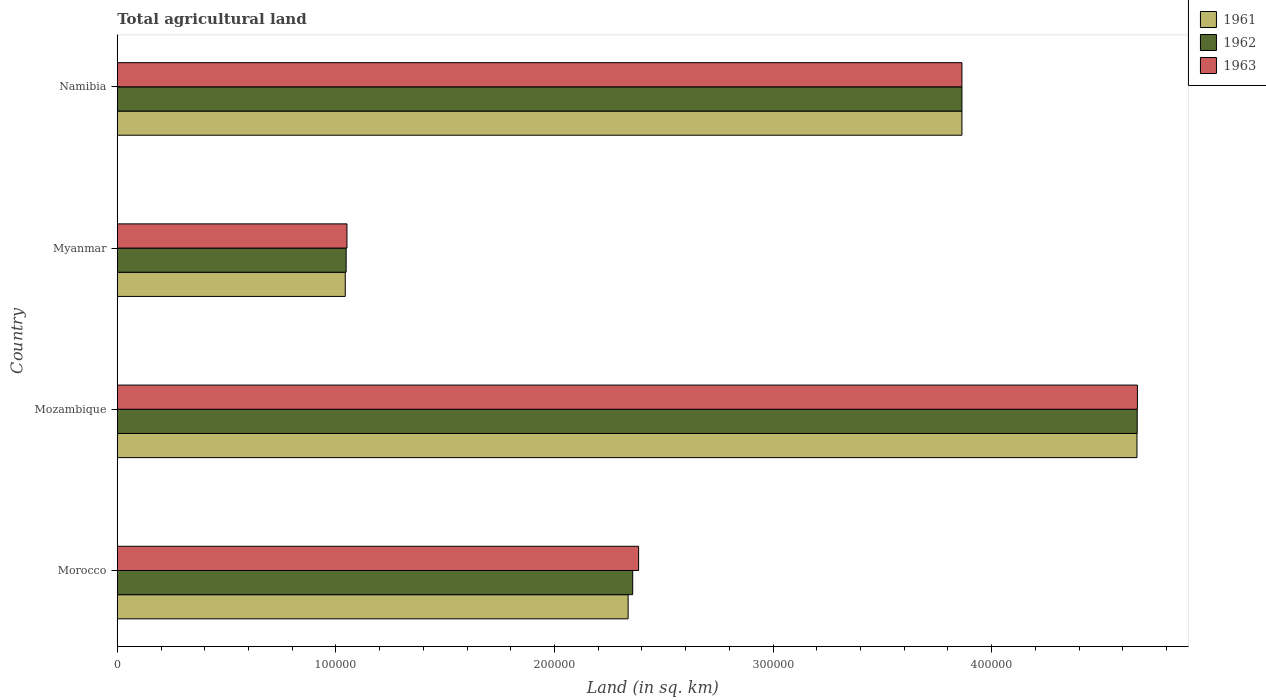How many different coloured bars are there?
Your answer should be compact. 3. How many groups of bars are there?
Provide a short and direct response. 4. How many bars are there on the 3rd tick from the top?
Your answer should be compact. 3. What is the label of the 1st group of bars from the top?
Provide a succinct answer. Namibia. In how many cases, is the number of bars for a given country not equal to the number of legend labels?
Provide a short and direct response. 0. What is the total agricultural land in 1962 in Namibia?
Your answer should be very brief. 3.86e+05. Across all countries, what is the maximum total agricultural land in 1961?
Your response must be concise. 4.66e+05. Across all countries, what is the minimum total agricultural land in 1962?
Give a very brief answer. 1.05e+05. In which country was the total agricultural land in 1963 maximum?
Give a very brief answer. Mozambique. In which country was the total agricultural land in 1962 minimum?
Your answer should be very brief. Myanmar. What is the total total agricultural land in 1963 in the graph?
Give a very brief answer. 1.20e+06. What is the difference between the total agricultural land in 1961 in Morocco and that in Mozambique?
Provide a succinct answer. -2.33e+05. What is the difference between the total agricultural land in 1961 in Myanmar and the total agricultural land in 1963 in Mozambique?
Your answer should be very brief. -3.62e+05. What is the average total agricultural land in 1961 per country?
Give a very brief answer. 2.98e+05. What is the difference between the total agricultural land in 1962 and total agricultural land in 1961 in Mozambique?
Your response must be concise. 110. What is the ratio of the total agricultural land in 1963 in Morocco to that in Myanmar?
Keep it short and to the point. 2.27. Is the total agricultural land in 1962 in Morocco less than that in Mozambique?
Make the answer very short. Yes. What is the difference between the highest and the second highest total agricultural land in 1961?
Your response must be concise. 8.01e+04. What is the difference between the highest and the lowest total agricultural land in 1961?
Make the answer very short. 3.62e+05. Is the sum of the total agricultural land in 1961 in Morocco and Myanmar greater than the maximum total agricultural land in 1962 across all countries?
Make the answer very short. No. What does the 3rd bar from the top in Myanmar represents?
Give a very brief answer. 1961. Is it the case that in every country, the sum of the total agricultural land in 1963 and total agricultural land in 1961 is greater than the total agricultural land in 1962?
Your answer should be very brief. Yes. How many bars are there?
Offer a very short reply. 12. How many countries are there in the graph?
Make the answer very short. 4. Are the values on the major ticks of X-axis written in scientific E-notation?
Your answer should be very brief. No. What is the title of the graph?
Your response must be concise. Total agricultural land. Does "1989" appear as one of the legend labels in the graph?
Your answer should be compact. No. What is the label or title of the X-axis?
Offer a terse response. Land (in sq. km). What is the label or title of the Y-axis?
Your response must be concise. Country. What is the Land (in sq. km) in 1961 in Morocco?
Your answer should be very brief. 2.34e+05. What is the Land (in sq. km) in 1962 in Morocco?
Ensure brevity in your answer.  2.36e+05. What is the Land (in sq. km) in 1963 in Morocco?
Your answer should be compact. 2.38e+05. What is the Land (in sq. km) in 1961 in Mozambique?
Provide a succinct answer. 4.66e+05. What is the Land (in sq. km) of 1962 in Mozambique?
Offer a terse response. 4.67e+05. What is the Land (in sq. km) of 1963 in Mozambique?
Keep it short and to the point. 4.67e+05. What is the Land (in sq. km) of 1961 in Myanmar?
Provide a short and direct response. 1.04e+05. What is the Land (in sq. km) of 1962 in Myanmar?
Your answer should be very brief. 1.05e+05. What is the Land (in sq. km) of 1963 in Myanmar?
Provide a short and direct response. 1.05e+05. What is the Land (in sq. km) of 1961 in Namibia?
Your answer should be very brief. 3.86e+05. What is the Land (in sq. km) of 1962 in Namibia?
Offer a terse response. 3.86e+05. What is the Land (in sq. km) in 1963 in Namibia?
Your answer should be compact. 3.86e+05. Across all countries, what is the maximum Land (in sq. km) of 1961?
Ensure brevity in your answer.  4.66e+05. Across all countries, what is the maximum Land (in sq. km) in 1962?
Ensure brevity in your answer.  4.67e+05. Across all countries, what is the maximum Land (in sq. km) in 1963?
Your answer should be compact. 4.67e+05. Across all countries, what is the minimum Land (in sq. km) of 1961?
Provide a succinct answer. 1.04e+05. Across all countries, what is the minimum Land (in sq. km) of 1962?
Provide a succinct answer. 1.05e+05. Across all countries, what is the minimum Land (in sq. km) of 1963?
Provide a succinct answer. 1.05e+05. What is the total Land (in sq. km) of 1961 in the graph?
Provide a succinct answer. 1.19e+06. What is the total Land (in sq. km) of 1962 in the graph?
Provide a succinct answer. 1.19e+06. What is the total Land (in sq. km) of 1963 in the graph?
Your response must be concise. 1.20e+06. What is the difference between the Land (in sq. km) in 1961 in Morocco and that in Mozambique?
Offer a very short reply. -2.33e+05. What is the difference between the Land (in sq. km) in 1962 in Morocco and that in Mozambique?
Offer a terse response. -2.31e+05. What is the difference between the Land (in sq. km) in 1963 in Morocco and that in Mozambique?
Your answer should be very brief. -2.28e+05. What is the difference between the Land (in sq. km) in 1961 in Morocco and that in Myanmar?
Keep it short and to the point. 1.29e+05. What is the difference between the Land (in sq. km) of 1962 in Morocco and that in Myanmar?
Keep it short and to the point. 1.31e+05. What is the difference between the Land (in sq. km) of 1963 in Morocco and that in Myanmar?
Your answer should be very brief. 1.33e+05. What is the difference between the Land (in sq. km) in 1961 in Morocco and that in Namibia?
Provide a short and direct response. -1.53e+05. What is the difference between the Land (in sq. km) of 1962 in Morocco and that in Namibia?
Ensure brevity in your answer.  -1.51e+05. What is the difference between the Land (in sq. km) of 1963 in Morocco and that in Namibia?
Keep it short and to the point. -1.48e+05. What is the difference between the Land (in sq. km) of 1961 in Mozambique and that in Myanmar?
Your answer should be very brief. 3.62e+05. What is the difference between the Land (in sq. km) of 1962 in Mozambique and that in Myanmar?
Your answer should be very brief. 3.62e+05. What is the difference between the Land (in sq. km) of 1963 in Mozambique and that in Myanmar?
Your answer should be compact. 3.62e+05. What is the difference between the Land (in sq. km) of 1961 in Mozambique and that in Namibia?
Make the answer very short. 8.01e+04. What is the difference between the Land (in sq. km) of 1962 in Mozambique and that in Namibia?
Give a very brief answer. 8.02e+04. What is the difference between the Land (in sq. km) in 1963 in Mozambique and that in Namibia?
Your answer should be compact. 8.03e+04. What is the difference between the Land (in sq. km) of 1961 in Myanmar and that in Namibia?
Ensure brevity in your answer.  -2.82e+05. What is the difference between the Land (in sq. km) of 1962 in Myanmar and that in Namibia?
Provide a short and direct response. -2.82e+05. What is the difference between the Land (in sq. km) of 1963 in Myanmar and that in Namibia?
Ensure brevity in your answer.  -2.81e+05. What is the difference between the Land (in sq. km) of 1961 in Morocco and the Land (in sq. km) of 1962 in Mozambique?
Your answer should be very brief. -2.33e+05. What is the difference between the Land (in sq. km) in 1961 in Morocco and the Land (in sq. km) in 1963 in Mozambique?
Your answer should be compact. -2.33e+05. What is the difference between the Land (in sq. km) of 1962 in Morocco and the Land (in sq. km) of 1963 in Mozambique?
Offer a very short reply. -2.31e+05. What is the difference between the Land (in sq. km) of 1961 in Morocco and the Land (in sq. km) of 1962 in Myanmar?
Make the answer very short. 1.29e+05. What is the difference between the Land (in sq. km) of 1961 in Morocco and the Land (in sq. km) of 1963 in Myanmar?
Provide a succinct answer. 1.29e+05. What is the difference between the Land (in sq. km) of 1962 in Morocco and the Land (in sq. km) of 1963 in Myanmar?
Your response must be concise. 1.31e+05. What is the difference between the Land (in sq. km) in 1961 in Morocco and the Land (in sq. km) in 1962 in Namibia?
Ensure brevity in your answer.  -1.53e+05. What is the difference between the Land (in sq. km) in 1961 in Morocco and the Land (in sq. km) in 1963 in Namibia?
Keep it short and to the point. -1.53e+05. What is the difference between the Land (in sq. km) of 1962 in Morocco and the Land (in sq. km) of 1963 in Namibia?
Provide a short and direct response. -1.51e+05. What is the difference between the Land (in sq. km) in 1961 in Mozambique and the Land (in sq. km) in 1962 in Myanmar?
Provide a succinct answer. 3.62e+05. What is the difference between the Land (in sq. km) of 1961 in Mozambique and the Land (in sq. km) of 1963 in Myanmar?
Offer a very short reply. 3.61e+05. What is the difference between the Land (in sq. km) in 1962 in Mozambique and the Land (in sq. km) in 1963 in Myanmar?
Your answer should be very brief. 3.62e+05. What is the difference between the Land (in sq. km) in 1961 in Mozambique and the Land (in sq. km) in 1962 in Namibia?
Make the answer very short. 8.01e+04. What is the difference between the Land (in sq. km) of 1961 in Mozambique and the Land (in sq. km) of 1963 in Namibia?
Your answer should be very brief. 8.01e+04. What is the difference between the Land (in sq. km) in 1962 in Mozambique and the Land (in sq. km) in 1963 in Namibia?
Your response must be concise. 8.02e+04. What is the difference between the Land (in sq. km) of 1961 in Myanmar and the Land (in sq. km) of 1962 in Namibia?
Provide a succinct answer. -2.82e+05. What is the difference between the Land (in sq. km) of 1961 in Myanmar and the Land (in sq. km) of 1963 in Namibia?
Give a very brief answer. -2.82e+05. What is the difference between the Land (in sq. km) of 1962 in Myanmar and the Land (in sq. km) of 1963 in Namibia?
Your answer should be compact. -2.82e+05. What is the average Land (in sq. km) in 1961 per country?
Ensure brevity in your answer.  2.98e+05. What is the average Land (in sq. km) of 1962 per country?
Ensure brevity in your answer.  2.98e+05. What is the average Land (in sq. km) of 1963 per country?
Your answer should be very brief. 2.99e+05. What is the difference between the Land (in sq. km) of 1961 and Land (in sq. km) of 1962 in Morocco?
Your answer should be compact. -2100. What is the difference between the Land (in sq. km) of 1961 and Land (in sq. km) of 1963 in Morocco?
Offer a terse response. -4800. What is the difference between the Land (in sq. km) of 1962 and Land (in sq. km) of 1963 in Morocco?
Ensure brevity in your answer.  -2700. What is the difference between the Land (in sq. km) in 1961 and Land (in sq. km) in 1962 in Mozambique?
Your response must be concise. -110. What is the difference between the Land (in sq. km) in 1961 and Land (in sq. km) in 1963 in Mozambique?
Provide a short and direct response. -210. What is the difference between the Land (in sq. km) of 1962 and Land (in sq. km) of 1963 in Mozambique?
Ensure brevity in your answer.  -100. What is the difference between the Land (in sq. km) of 1961 and Land (in sq. km) of 1962 in Myanmar?
Your response must be concise. -400. What is the difference between the Land (in sq. km) in 1961 and Land (in sq. km) in 1963 in Myanmar?
Provide a succinct answer. -770. What is the difference between the Land (in sq. km) of 1962 and Land (in sq. km) of 1963 in Myanmar?
Keep it short and to the point. -370. What is the difference between the Land (in sq. km) of 1961 and Land (in sq. km) of 1963 in Namibia?
Ensure brevity in your answer.  0. What is the ratio of the Land (in sq. km) in 1961 in Morocco to that in Mozambique?
Give a very brief answer. 0.5. What is the ratio of the Land (in sq. km) of 1962 in Morocco to that in Mozambique?
Give a very brief answer. 0.51. What is the ratio of the Land (in sq. km) of 1963 in Morocco to that in Mozambique?
Give a very brief answer. 0.51. What is the ratio of the Land (in sq. km) in 1961 in Morocco to that in Myanmar?
Your answer should be compact. 2.24. What is the ratio of the Land (in sq. km) of 1962 in Morocco to that in Myanmar?
Give a very brief answer. 2.25. What is the ratio of the Land (in sq. km) in 1963 in Morocco to that in Myanmar?
Ensure brevity in your answer.  2.27. What is the ratio of the Land (in sq. km) in 1961 in Morocco to that in Namibia?
Offer a terse response. 0.6. What is the ratio of the Land (in sq. km) in 1962 in Morocco to that in Namibia?
Make the answer very short. 0.61. What is the ratio of the Land (in sq. km) of 1963 in Morocco to that in Namibia?
Your answer should be compact. 0.62. What is the ratio of the Land (in sq. km) of 1961 in Mozambique to that in Myanmar?
Offer a terse response. 4.47. What is the ratio of the Land (in sq. km) in 1962 in Mozambique to that in Myanmar?
Ensure brevity in your answer.  4.46. What is the ratio of the Land (in sq. km) of 1963 in Mozambique to that in Myanmar?
Provide a short and direct response. 4.44. What is the ratio of the Land (in sq. km) in 1961 in Mozambique to that in Namibia?
Provide a succinct answer. 1.21. What is the ratio of the Land (in sq. km) of 1962 in Mozambique to that in Namibia?
Your response must be concise. 1.21. What is the ratio of the Land (in sq. km) of 1963 in Mozambique to that in Namibia?
Your answer should be compact. 1.21. What is the ratio of the Land (in sq. km) in 1961 in Myanmar to that in Namibia?
Provide a succinct answer. 0.27. What is the ratio of the Land (in sq. km) of 1962 in Myanmar to that in Namibia?
Provide a succinct answer. 0.27. What is the ratio of the Land (in sq. km) in 1963 in Myanmar to that in Namibia?
Keep it short and to the point. 0.27. What is the difference between the highest and the second highest Land (in sq. km) in 1961?
Your answer should be compact. 8.01e+04. What is the difference between the highest and the second highest Land (in sq. km) in 1962?
Offer a very short reply. 8.02e+04. What is the difference between the highest and the second highest Land (in sq. km) of 1963?
Offer a terse response. 8.03e+04. What is the difference between the highest and the lowest Land (in sq. km) in 1961?
Keep it short and to the point. 3.62e+05. What is the difference between the highest and the lowest Land (in sq. km) in 1962?
Provide a short and direct response. 3.62e+05. What is the difference between the highest and the lowest Land (in sq. km) of 1963?
Your answer should be very brief. 3.62e+05. 